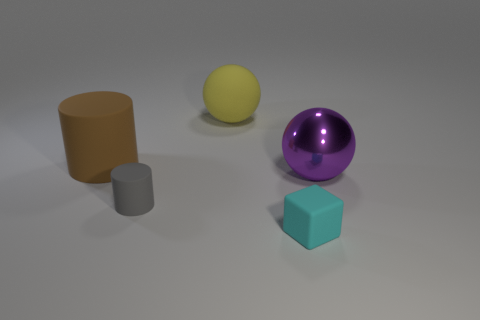Are there any other things that have the same material as the purple thing?
Keep it short and to the point. No. How many other things are the same material as the tiny block?
Ensure brevity in your answer.  3. Are there an equal number of yellow rubber things to the left of the brown thing and big red metal cubes?
Offer a terse response. Yes. The large ball left of the small object on the right side of the ball that is to the left of the big purple thing is made of what material?
Offer a terse response. Rubber. The ball that is behind the purple sphere is what color?
Keep it short and to the point. Yellow. Are there any other things that have the same shape as the tiny cyan rubber thing?
Ensure brevity in your answer.  No. What size is the matte thing that is in front of the cylinder on the right side of the brown cylinder?
Offer a very short reply. Small. Are there an equal number of large purple objects that are behind the big yellow object and gray things behind the large brown object?
Ensure brevity in your answer.  Yes. Is there anything else that has the same size as the brown matte thing?
Provide a short and direct response. Yes. There is a big sphere that is the same material as the small cylinder; what is its color?
Ensure brevity in your answer.  Yellow. 